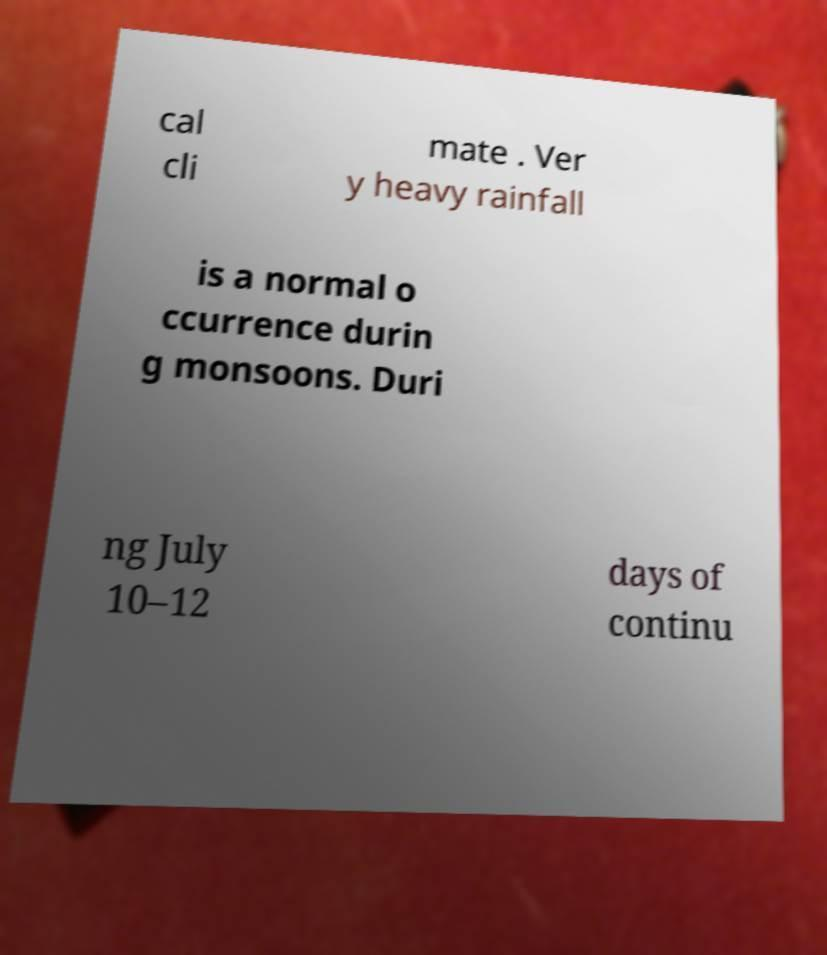For documentation purposes, I need the text within this image transcribed. Could you provide that? cal cli mate . Ver y heavy rainfall is a normal o ccurrence durin g monsoons. Duri ng July 10–12 days of continu 